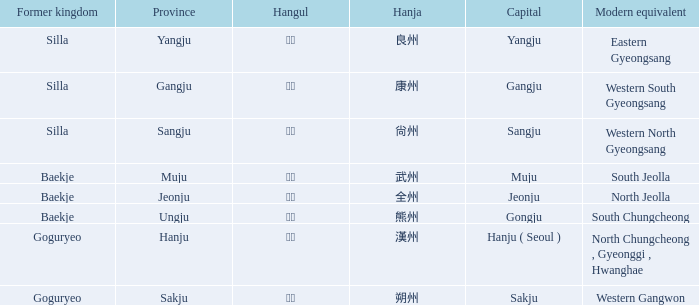What is the modern equivalent of the former kingdom "silla" with the hanja 尙州? 1.0. 